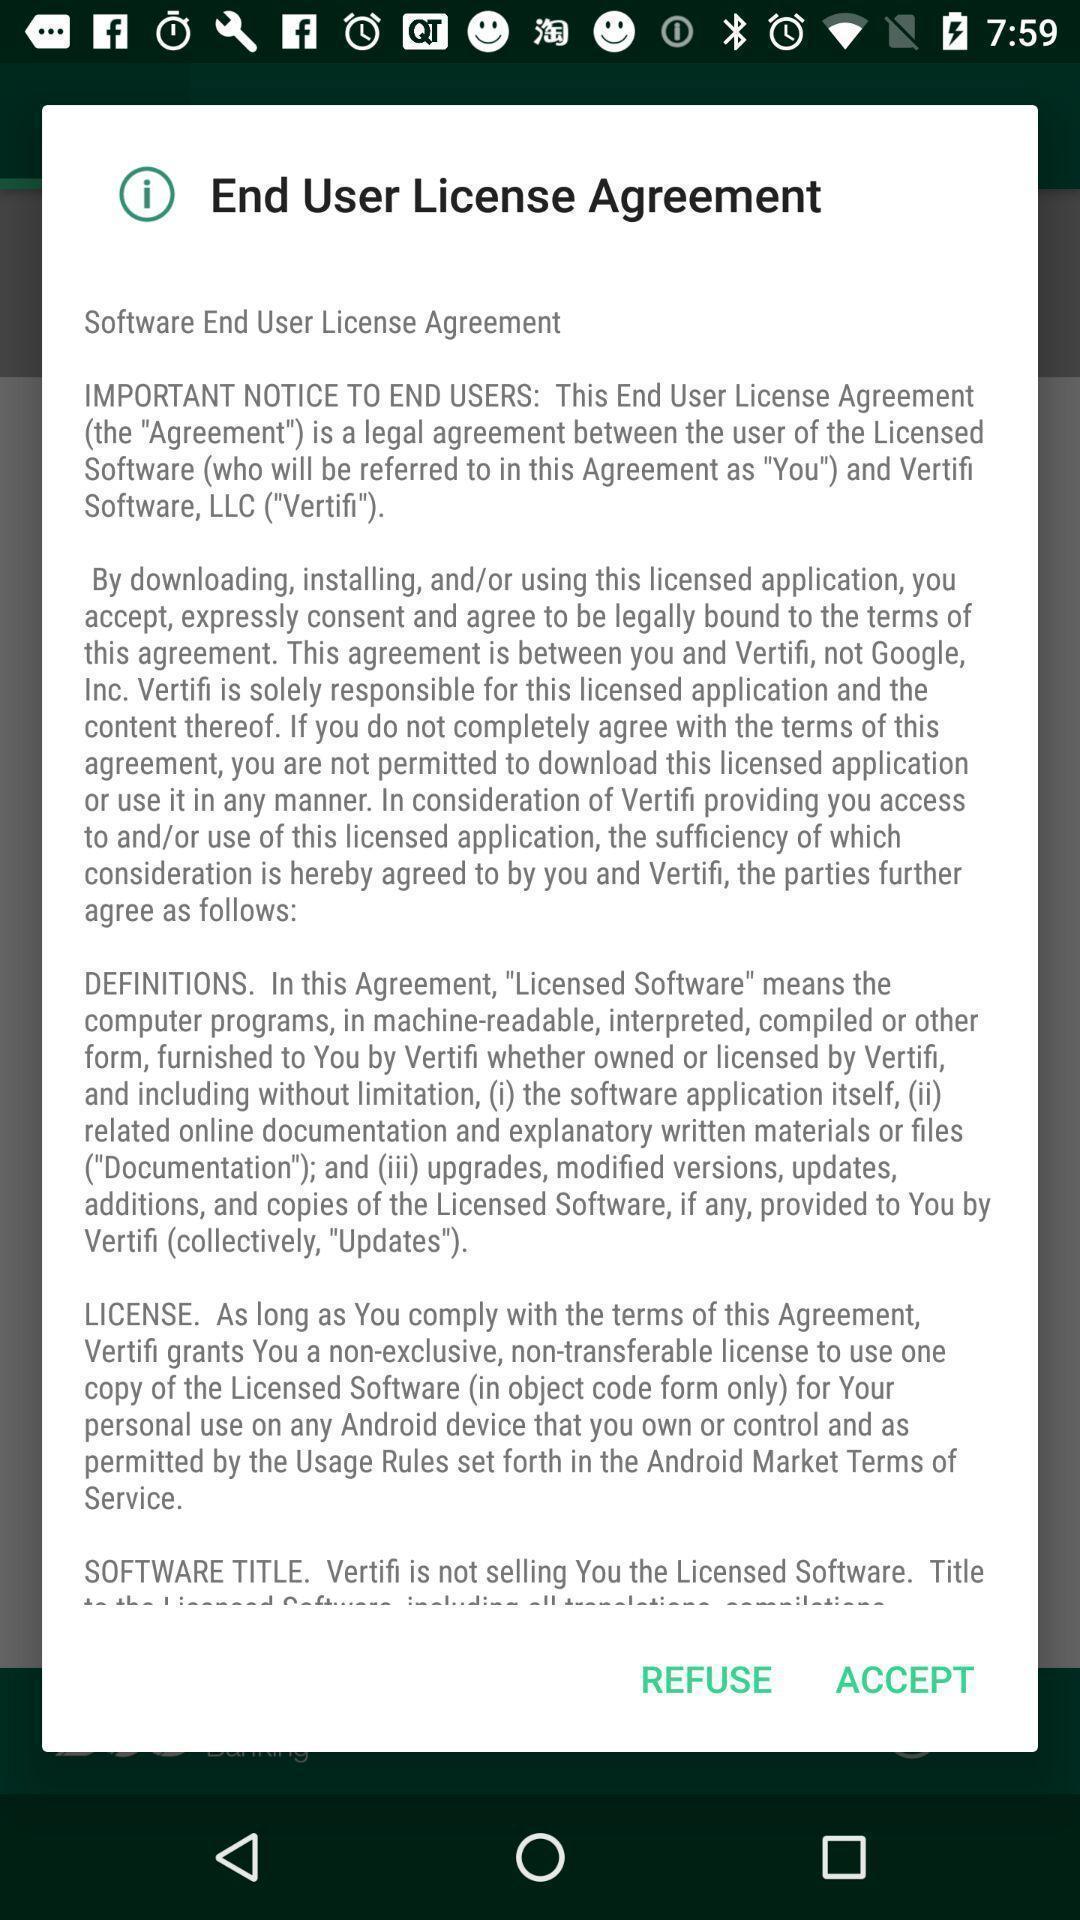Provide a description of this screenshot. Popup displaying license agreement information. 